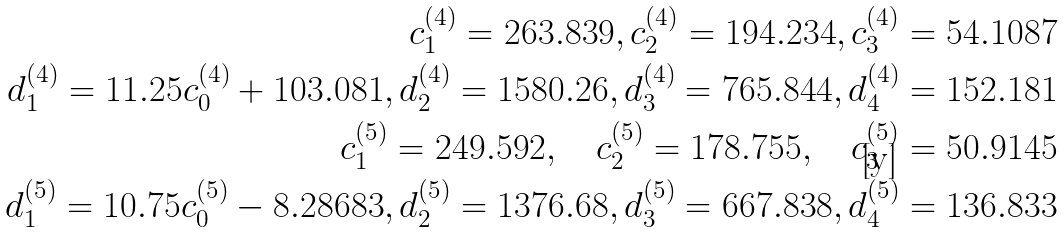<formula> <loc_0><loc_0><loc_500><loc_500>c _ { 1 } ^ { ( 4 ) } = 2 6 3 . 8 3 9 , c _ { 2 } ^ { ( 4 ) } = 1 9 4 . 2 3 4 , c _ { 3 } ^ { ( 4 ) } = 5 4 . 1 0 8 7 \\ d _ { 1 } ^ { ( 4 ) } = 1 1 . 2 5 c _ { 0 } ^ { ( 4 ) } + 1 0 3 . 0 8 1 , d _ { 2 } ^ { ( 4 ) } = 1 5 8 0 . 2 6 , d _ { 3 } ^ { ( 4 ) } = 7 6 5 . 8 4 4 , d _ { 4 } ^ { ( 4 ) } = 1 5 2 . 1 8 1 \\ c _ { 1 } ^ { ( 5 ) } = 2 4 9 . 5 9 2 , \quad c _ { 2 } ^ { ( 5 ) } = 1 7 8 . 7 5 5 , \quad c _ { 3 } ^ { ( 5 ) } = 5 0 . 9 1 4 5 \\ d _ { 1 } ^ { ( 5 ) } = 1 0 . 7 5 c _ { 0 } ^ { ( 5 ) } - 8 . 2 8 6 8 3 , d _ { 2 } ^ { ( 5 ) } = 1 3 7 6 . 6 8 , d _ { 3 } ^ { ( 5 ) } = 6 6 7 . 8 3 8 , d _ { 4 } ^ { ( 5 ) } = 1 3 6 . 8 3 3</formula> 